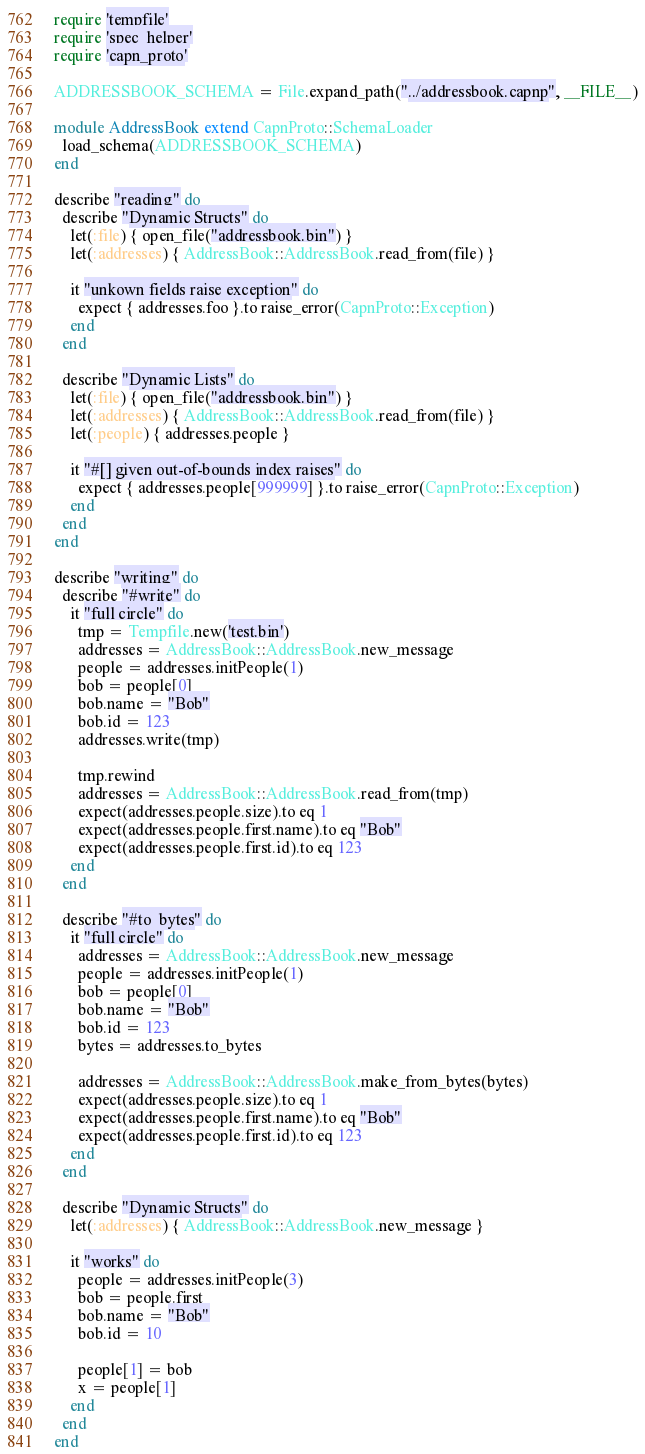Convert code to text. <code><loc_0><loc_0><loc_500><loc_500><_Ruby_>require 'tempfile'
require 'spec_helper'
require 'capn_proto'

ADDRESSBOOK_SCHEMA = File.expand_path("../addressbook.capnp", __FILE__)

module AddressBook extend CapnProto::SchemaLoader
  load_schema(ADDRESSBOOK_SCHEMA)
end

describe "reading" do
  describe "Dynamic Structs" do
    let(:file) { open_file("addressbook.bin") }
    let(:addresses) { AddressBook::AddressBook.read_from(file) }

    it "unkown fields raise exception" do
      expect { addresses.foo }.to raise_error(CapnProto::Exception)
    end
  end

  describe "Dynamic Lists" do
    let(:file) { open_file("addressbook.bin") }
    let(:addresses) { AddressBook::AddressBook.read_from(file) }
    let(:people) { addresses.people }

    it "#[] given out-of-bounds index raises" do
      expect { addresses.people[999999] }.to raise_error(CapnProto::Exception)
    end
  end
end

describe "writing" do
  describe "#write" do
    it "full circle" do
      tmp = Tempfile.new('test.bin')
      addresses = AddressBook::AddressBook.new_message
      people = addresses.initPeople(1)
      bob = people[0]
      bob.name = "Bob"
      bob.id = 123
      addresses.write(tmp)

      tmp.rewind
      addresses = AddressBook::AddressBook.read_from(tmp)
      expect(addresses.people.size).to eq 1
      expect(addresses.people.first.name).to eq "Bob"
      expect(addresses.people.first.id).to eq 123
    end
  end

  describe "#to_bytes" do
    it "full circle" do
      addresses = AddressBook::AddressBook.new_message
      people = addresses.initPeople(1)
      bob = people[0]
      bob.name = "Bob"
      bob.id = 123
      bytes = addresses.to_bytes

      addresses = AddressBook::AddressBook.make_from_bytes(bytes)
      expect(addresses.people.size).to eq 1
      expect(addresses.people.first.name).to eq "Bob"
      expect(addresses.people.first.id).to eq 123
    end
  end

  describe "Dynamic Structs" do
    let(:addresses) { AddressBook::AddressBook.new_message }

    it "works" do
      people = addresses.initPeople(3)
      bob = people.first
      bob.name = "Bob"
      bob.id = 10

      people[1] = bob
      x = people[1]
    end
  end
end
</code> 